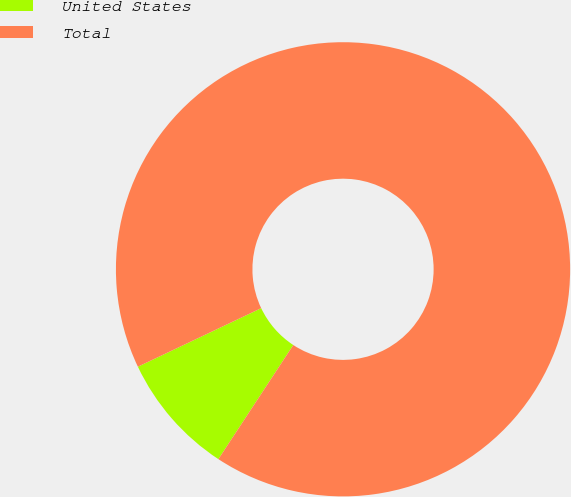<chart> <loc_0><loc_0><loc_500><loc_500><pie_chart><fcel>United States<fcel>Total<nl><fcel>8.7%<fcel>91.3%<nl></chart> 